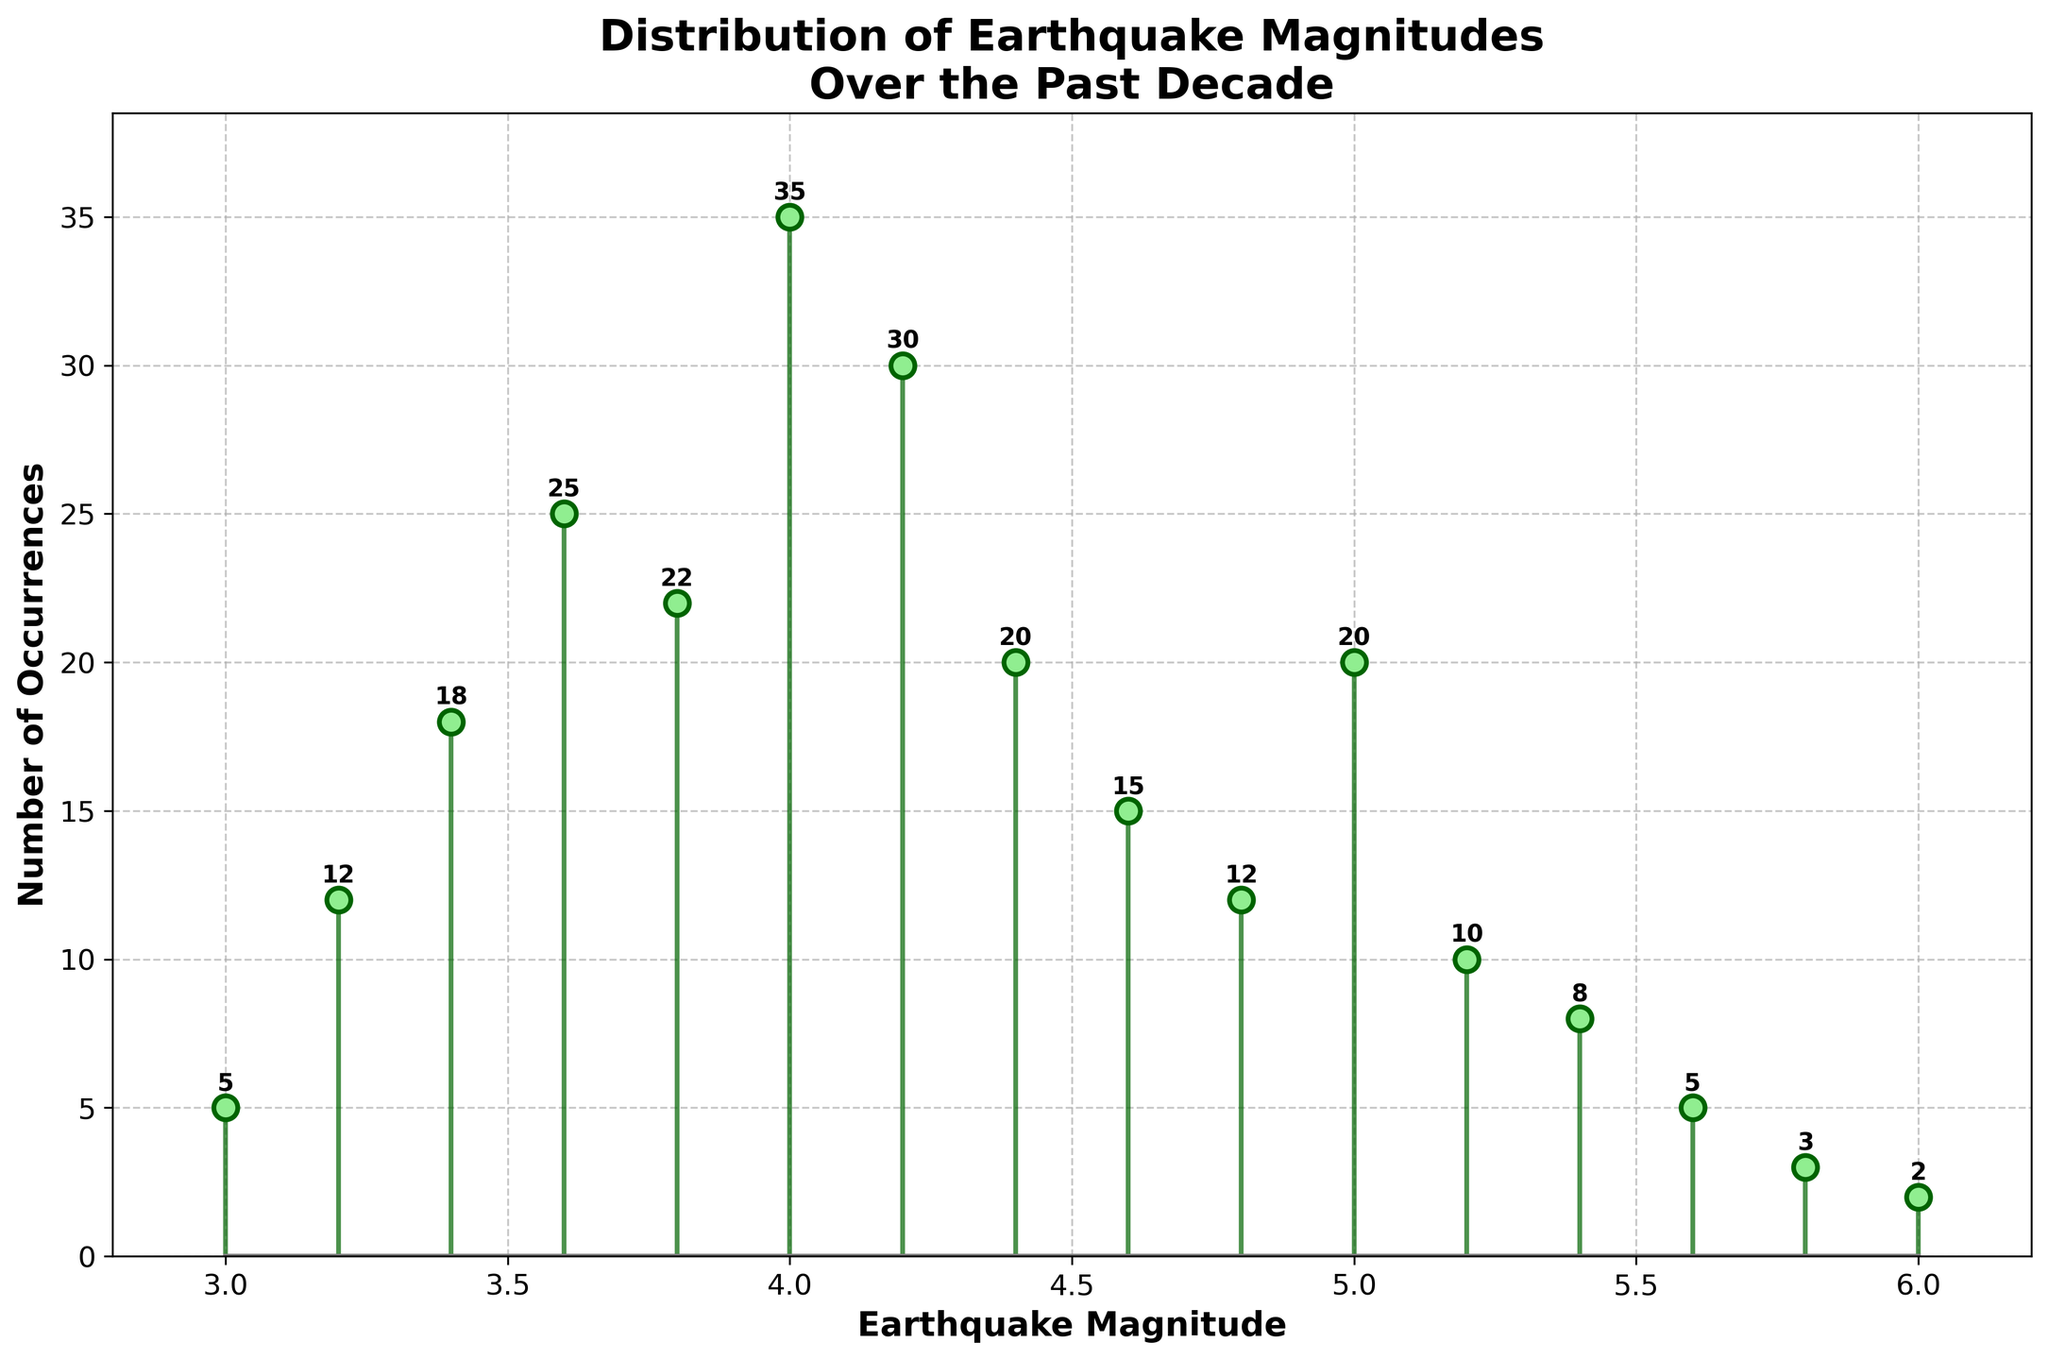What is the title of the plot? The title is usually displayed at the top of the figure to provide a summary of what the plot represents. In this case, it tells us about the data being visualized.
Answer: Distribution of Earthquake Magnitudes Over the Past Decade What are the labels on the axes? Axis labels typically describe what data is being represented. The x-axis label represents the earthquake magnitude, and the y-axis label represents the number of occurrences.
Answer: Earthquake Magnitude (x-axis) and Number of Occurrences (y-axis) What is the range of the x-axis? The range of the x-axis is determined by the minimum and maximum values shown on the axis, which correspond to the earthquake magnitudes.
Answer: 2.8 to 6.2 Which earthquake magnitude has the highest number of occurrences? To find this, look for the tallest stem in the plot and check the corresponding magnitude value on the x-axis.
Answer: 4.0 How many times did earthquakes with a magnitude of 5.0 occur? Identify the stem corresponding to the magnitude of 5.0 and read the number of occurrences directly from the plot's annotation or the y-axis.
Answer: 20 What is the total number of earthquakes recorded in the region over the past decade? Sum the counts of all occurrences shown for each magnitude. Adding them all gives the total number of earthquakes.
Answer: 242 How does the number of earthquakes with a magnitude of 3.6 compare to those with a magnitude of 5.2? Compare the heights of the stems for magnitudes 3.6 and 5.2 directly on the plot.
Answer: 3.6 has 25 occurrences; 5.2 has 10 occurrences. 3.6 > 5.2 Which magnitude range (3.0-3.4 or 5.4-6.0) has a higher total number of earthquakes? Sum the counts for magnitudes 3.0 to 3.4 and compare the total with the sum of counts from magnitudes 5.4 to 6.0.
Answer: 3.0-3.4: 5 + 12 + 18 = 35, 5.4-6.0: 8 + 5 + 3 + 2 = 18. 3.0-3.4 > 5.4-6.0 What is the trend in the number of occurrences as earthquake magnitude increases from 3.0 to 4.0? Observe the pattern and general shape of the stems from magnitude 3.0 to 4.0.
Answer: Increasing trend Which magnitudes have the fewest number of occurrences? Look for the shortest stems in the plot.
Answer: 6.0 